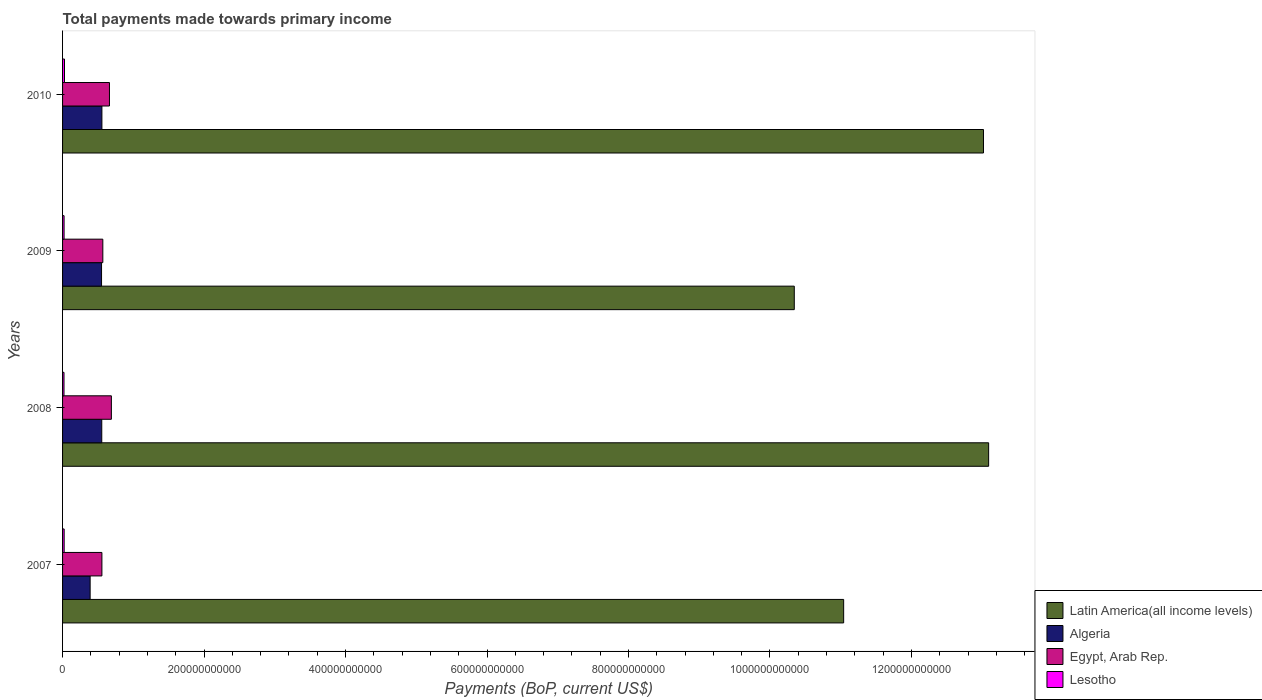How many groups of bars are there?
Offer a terse response. 4. Are the number of bars per tick equal to the number of legend labels?
Offer a very short reply. Yes. Are the number of bars on each tick of the Y-axis equal?
Your answer should be very brief. Yes. How many bars are there on the 1st tick from the top?
Make the answer very short. 4. How many bars are there on the 4th tick from the bottom?
Ensure brevity in your answer.  4. In how many cases, is the number of bars for a given year not equal to the number of legend labels?
Offer a very short reply. 0. What is the total payments made towards primary income in Latin America(all income levels) in 2010?
Make the answer very short. 1.30e+12. Across all years, what is the maximum total payments made towards primary income in Algeria?
Ensure brevity in your answer.  5.56e+1. Across all years, what is the minimum total payments made towards primary income in Latin America(all income levels)?
Offer a very short reply. 1.03e+12. In which year was the total payments made towards primary income in Algeria minimum?
Make the answer very short. 2007. What is the total total payments made towards primary income in Algeria in the graph?
Keep it short and to the point. 2.05e+11. What is the difference between the total payments made towards primary income in Lesotho in 2008 and that in 2009?
Offer a very short reply. -1.04e+08. What is the difference between the total payments made towards primary income in Egypt, Arab Rep. in 2008 and the total payments made towards primary income in Latin America(all income levels) in 2007?
Provide a succinct answer. -1.04e+12. What is the average total payments made towards primary income in Algeria per year?
Give a very brief answer. 5.13e+1. In the year 2008, what is the difference between the total payments made towards primary income in Algeria and total payments made towards primary income in Latin America(all income levels)?
Your answer should be very brief. -1.25e+12. What is the ratio of the total payments made towards primary income in Lesotho in 2008 to that in 2009?
Your response must be concise. 0.95. Is the total payments made towards primary income in Lesotho in 2007 less than that in 2010?
Provide a succinct answer. Yes. Is the difference between the total payments made towards primary income in Algeria in 2008 and 2009 greater than the difference between the total payments made towards primary income in Latin America(all income levels) in 2008 and 2009?
Ensure brevity in your answer.  No. What is the difference between the highest and the second highest total payments made towards primary income in Latin America(all income levels)?
Your answer should be compact. 7.28e+09. What is the difference between the highest and the lowest total payments made towards primary income in Algeria?
Keep it short and to the point. 1.66e+1. Is the sum of the total payments made towards primary income in Lesotho in 2007 and 2009 greater than the maximum total payments made towards primary income in Egypt, Arab Rep. across all years?
Ensure brevity in your answer.  No. Is it the case that in every year, the sum of the total payments made towards primary income in Egypt, Arab Rep. and total payments made towards primary income in Algeria is greater than the sum of total payments made towards primary income in Lesotho and total payments made towards primary income in Latin America(all income levels)?
Offer a very short reply. No. What does the 4th bar from the top in 2008 represents?
Keep it short and to the point. Latin America(all income levels). What does the 1st bar from the bottom in 2010 represents?
Offer a terse response. Latin America(all income levels). Are all the bars in the graph horizontal?
Your response must be concise. Yes. How many years are there in the graph?
Offer a very short reply. 4. What is the difference between two consecutive major ticks on the X-axis?
Your answer should be compact. 2.00e+11. Are the values on the major ticks of X-axis written in scientific E-notation?
Your response must be concise. No. Does the graph contain grids?
Offer a very short reply. No. How many legend labels are there?
Give a very brief answer. 4. What is the title of the graph?
Your answer should be very brief. Total payments made towards primary income. What is the label or title of the X-axis?
Keep it short and to the point. Payments (BoP, current US$). What is the Payments (BoP, current US$) in Latin America(all income levels) in 2007?
Make the answer very short. 1.10e+12. What is the Payments (BoP, current US$) in Algeria in 2007?
Offer a terse response. 3.90e+1. What is the Payments (BoP, current US$) in Egypt, Arab Rep. in 2007?
Keep it short and to the point. 5.56e+1. What is the Payments (BoP, current US$) in Lesotho in 2007?
Offer a terse response. 2.25e+09. What is the Payments (BoP, current US$) in Latin America(all income levels) in 2008?
Your answer should be very brief. 1.31e+12. What is the Payments (BoP, current US$) of Algeria in 2008?
Offer a very short reply. 5.54e+1. What is the Payments (BoP, current US$) of Egypt, Arab Rep. in 2008?
Provide a short and direct response. 6.90e+1. What is the Payments (BoP, current US$) in Lesotho in 2008?
Your response must be concise. 2.03e+09. What is the Payments (BoP, current US$) of Latin America(all income levels) in 2009?
Offer a very short reply. 1.03e+12. What is the Payments (BoP, current US$) of Algeria in 2009?
Your answer should be very brief. 5.51e+1. What is the Payments (BoP, current US$) of Egypt, Arab Rep. in 2009?
Keep it short and to the point. 5.69e+1. What is the Payments (BoP, current US$) in Lesotho in 2009?
Provide a short and direct response. 2.14e+09. What is the Payments (BoP, current US$) of Latin America(all income levels) in 2010?
Ensure brevity in your answer.  1.30e+12. What is the Payments (BoP, current US$) of Algeria in 2010?
Offer a terse response. 5.56e+1. What is the Payments (BoP, current US$) in Egypt, Arab Rep. in 2010?
Ensure brevity in your answer.  6.63e+1. What is the Payments (BoP, current US$) in Lesotho in 2010?
Offer a terse response. 2.74e+09. Across all years, what is the maximum Payments (BoP, current US$) of Latin America(all income levels)?
Your answer should be very brief. 1.31e+12. Across all years, what is the maximum Payments (BoP, current US$) of Algeria?
Your response must be concise. 5.56e+1. Across all years, what is the maximum Payments (BoP, current US$) in Egypt, Arab Rep.?
Keep it short and to the point. 6.90e+1. Across all years, what is the maximum Payments (BoP, current US$) of Lesotho?
Ensure brevity in your answer.  2.74e+09. Across all years, what is the minimum Payments (BoP, current US$) in Latin America(all income levels)?
Offer a very short reply. 1.03e+12. Across all years, what is the minimum Payments (BoP, current US$) in Algeria?
Offer a very short reply. 3.90e+1. Across all years, what is the minimum Payments (BoP, current US$) of Egypt, Arab Rep.?
Offer a very short reply. 5.56e+1. Across all years, what is the minimum Payments (BoP, current US$) in Lesotho?
Make the answer very short. 2.03e+09. What is the total Payments (BoP, current US$) in Latin America(all income levels) in the graph?
Provide a short and direct response. 4.75e+12. What is the total Payments (BoP, current US$) in Algeria in the graph?
Keep it short and to the point. 2.05e+11. What is the total Payments (BoP, current US$) in Egypt, Arab Rep. in the graph?
Provide a succinct answer. 2.48e+11. What is the total Payments (BoP, current US$) of Lesotho in the graph?
Your answer should be very brief. 9.17e+09. What is the difference between the Payments (BoP, current US$) in Latin America(all income levels) in 2007 and that in 2008?
Your response must be concise. -2.05e+11. What is the difference between the Payments (BoP, current US$) of Algeria in 2007 and that in 2008?
Make the answer very short. -1.64e+1. What is the difference between the Payments (BoP, current US$) in Egypt, Arab Rep. in 2007 and that in 2008?
Make the answer very short. -1.34e+1. What is the difference between the Payments (BoP, current US$) of Lesotho in 2007 and that in 2008?
Give a very brief answer. 2.17e+08. What is the difference between the Payments (BoP, current US$) in Latin America(all income levels) in 2007 and that in 2009?
Your answer should be compact. 6.98e+1. What is the difference between the Payments (BoP, current US$) in Algeria in 2007 and that in 2009?
Keep it short and to the point. -1.61e+1. What is the difference between the Payments (BoP, current US$) in Egypt, Arab Rep. in 2007 and that in 2009?
Your response must be concise. -1.29e+09. What is the difference between the Payments (BoP, current US$) of Lesotho in 2007 and that in 2009?
Your response must be concise. 1.13e+08. What is the difference between the Payments (BoP, current US$) of Latin America(all income levels) in 2007 and that in 2010?
Offer a very short reply. -1.98e+11. What is the difference between the Payments (BoP, current US$) in Algeria in 2007 and that in 2010?
Ensure brevity in your answer.  -1.66e+1. What is the difference between the Payments (BoP, current US$) of Egypt, Arab Rep. in 2007 and that in 2010?
Your response must be concise. -1.07e+1. What is the difference between the Payments (BoP, current US$) in Lesotho in 2007 and that in 2010?
Keep it short and to the point. -4.89e+08. What is the difference between the Payments (BoP, current US$) in Latin America(all income levels) in 2008 and that in 2009?
Ensure brevity in your answer.  2.75e+11. What is the difference between the Payments (BoP, current US$) in Algeria in 2008 and that in 2009?
Give a very brief answer. 2.97e+08. What is the difference between the Payments (BoP, current US$) in Egypt, Arab Rep. in 2008 and that in 2009?
Your answer should be very brief. 1.21e+1. What is the difference between the Payments (BoP, current US$) in Lesotho in 2008 and that in 2009?
Offer a terse response. -1.04e+08. What is the difference between the Payments (BoP, current US$) of Latin America(all income levels) in 2008 and that in 2010?
Provide a short and direct response. 7.28e+09. What is the difference between the Payments (BoP, current US$) of Algeria in 2008 and that in 2010?
Your answer should be compact. -2.06e+08. What is the difference between the Payments (BoP, current US$) of Egypt, Arab Rep. in 2008 and that in 2010?
Keep it short and to the point. 2.69e+09. What is the difference between the Payments (BoP, current US$) of Lesotho in 2008 and that in 2010?
Keep it short and to the point. -7.06e+08. What is the difference between the Payments (BoP, current US$) of Latin America(all income levels) in 2009 and that in 2010?
Ensure brevity in your answer.  -2.67e+11. What is the difference between the Payments (BoP, current US$) in Algeria in 2009 and that in 2010?
Your answer should be compact. -5.04e+08. What is the difference between the Payments (BoP, current US$) in Egypt, Arab Rep. in 2009 and that in 2010?
Ensure brevity in your answer.  -9.40e+09. What is the difference between the Payments (BoP, current US$) of Lesotho in 2009 and that in 2010?
Make the answer very short. -6.02e+08. What is the difference between the Payments (BoP, current US$) in Latin America(all income levels) in 2007 and the Payments (BoP, current US$) in Algeria in 2008?
Keep it short and to the point. 1.05e+12. What is the difference between the Payments (BoP, current US$) in Latin America(all income levels) in 2007 and the Payments (BoP, current US$) in Egypt, Arab Rep. in 2008?
Make the answer very short. 1.04e+12. What is the difference between the Payments (BoP, current US$) of Latin America(all income levels) in 2007 and the Payments (BoP, current US$) of Lesotho in 2008?
Your answer should be very brief. 1.10e+12. What is the difference between the Payments (BoP, current US$) in Algeria in 2007 and the Payments (BoP, current US$) in Egypt, Arab Rep. in 2008?
Provide a short and direct response. -3.00e+1. What is the difference between the Payments (BoP, current US$) in Algeria in 2007 and the Payments (BoP, current US$) in Lesotho in 2008?
Your answer should be very brief. 3.69e+1. What is the difference between the Payments (BoP, current US$) in Egypt, Arab Rep. in 2007 and the Payments (BoP, current US$) in Lesotho in 2008?
Your answer should be very brief. 5.36e+1. What is the difference between the Payments (BoP, current US$) in Latin America(all income levels) in 2007 and the Payments (BoP, current US$) in Algeria in 2009?
Provide a succinct answer. 1.05e+12. What is the difference between the Payments (BoP, current US$) of Latin America(all income levels) in 2007 and the Payments (BoP, current US$) of Egypt, Arab Rep. in 2009?
Ensure brevity in your answer.  1.05e+12. What is the difference between the Payments (BoP, current US$) in Latin America(all income levels) in 2007 and the Payments (BoP, current US$) in Lesotho in 2009?
Ensure brevity in your answer.  1.10e+12. What is the difference between the Payments (BoP, current US$) in Algeria in 2007 and the Payments (BoP, current US$) in Egypt, Arab Rep. in 2009?
Ensure brevity in your answer.  -1.79e+1. What is the difference between the Payments (BoP, current US$) of Algeria in 2007 and the Payments (BoP, current US$) of Lesotho in 2009?
Provide a short and direct response. 3.68e+1. What is the difference between the Payments (BoP, current US$) of Egypt, Arab Rep. in 2007 and the Payments (BoP, current US$) of Lesotho in 2009?
Keep it short and to the point. 5.35e+1. What is the difference between the Payments (BoP, current US$) in Latin America(all income levels) in 2007 and the Payments (BoP, current US$) in Algeria in 2010?
Your answer should be very brief. 1.05e+12. What is the difference between the Payments (BoP, current US$) in Latin America(all income levels) in 2007 and the Payments (BoP, current US$) in Egypt, Arab Rep. in 2010?
Keep it short and to the point. 1.04e+12. What is the difference between the Payments (BoP, current US$) in Latin America(all income levels) in 2007 and the Payments (BoP, current US$) in Lesotho in 2010?
Keep it short and to the point. 1.10e+12. What is the difference between the Payments (BoP, current US$) in Algeria in 2007 and the Payments (BoP, current US$) in Egypt, Arab Rep. in 2010?
Offer a very short reply. -2.73e+1. What is the difference between the Payments (BoP, current US$) of Algeria in 2007 and the Payments (BoP, current US$) of Lesotho in 2010?
Your response must be concise. 3.62e+1. What is the difference between the Payments (BoP, current US$) in Egypt, Arab Rep. in 2007 and the Payments (BoP, current US$) in Lesotho in 2010?
Your response must be concise. 5.29e+1. What is the difference between the Payments (BoP, current US$) in Latin America(all income levels) in 2008 and the Payments (BoP, current US$) in Algeria in 2009?
Your answer should be compact. 1.25e+12. What is the difference between the Payments (BoP, current US$) in Latin America(all income levels) in 2008 and the Payments (BoP, current US$) in Egypt, Arab Rep. in 2009?
Your response must be concise. 1.25e+12. What is the difference between the Payments (BoP, current US$) in Latin America(all income levels) in 2008 and the Payments (BoP, current US$) in Lesotho in 2009?
Offer a terse response. 1.31e+12. What is the difference between the Payments (BoP, current US$) in Algeria in 2008 and the Payments (BoP, current US$) in Egypt, Arab Rep. in 2009?
Ensure brevity in your answer.  -1.50e+09. What is the difference between the Payments (BoP, current US$) of Algeria in 2008 and the Payments (BoP, current US$) of Lesotho in 2009?
Your response must be concise. 5.33e+1. What is the difference between the Payments (BoP, current US$) of Egypt, Arab Rep. in 2008 and the Payments (BoP, current US$) of Lesotho in 2009?
Ensure brevity in your answer.  6.69e+1. What is the difference between the Payments (BoP, current US$) of Latin America(all income levels) in 2008 and the Payments (BoP, current US$) of Algeria in 2010?
Ensure brevity in your answer.  1.25e+12. What is the difference between the Payments (BoP, current US$) in Latin America(all income levels) in 2008 and the Payments (BoP, current US$) in Egypt, Arab Rep. in 2010?
Your answer should be very brief. 1.24e+12. What is the difference between the Payments (BoP, current US$) of Latin America(all income levels) in 2008 and the Payments (BoP, current US$) of Lesotho in 2010?
Provide a short and direct response. 1.31e+12. What is the difference between the Payments (BoP, current US$) in Algeria in 2008 and the Payments (BoP, current US$) in Egypt, Arab Rep. in 2010?
Provide a succinct answer. -1.09e+1. What is the difference between the Payments (BoP, current US$) of Algeria in 2008 and the Payments (BoP, current US$) of Lesotho in 2010?
Your answer should be very brief. 5.27e+1. What is the difference between the Payments (BoP, current US$) of Egypt, Arab Rep. in 2008 and the Payments (BoP, current US$) of Lesotho in 2010?
Ensure brevity in your answer.  6.63e+1. What is the difference between the Payments (BoP, current US$) in Latin America(all income levels) in 2009 and the Payments (BoP, current US$) in Algeria in 2010?
Offer a very short reply. 9.79e+11. What is the difference between the Payments (BoP, current US$) of Latin America(all income levels) in 2009 and the Payments (BoP, current US$) of Egypt, Arab Rep. in 2010?
Provide a short and direct response. 9.68e+11. What is the difference between the Payments (BoP, current US$) in Latin America(all income levels) in 2009 and the Payments (BoP, current US$) in Lesotho in 2010?
Offer a terse response. 1.03e+12. What is the difference between the Payments (BoP, current US$) of Algeria in 2009 and the Payments (BoP, current US$) of Egypt, Arab Rep. in 2010?
Your answer should be very brief. -1.12e+1. What is the difference between the Payments (BoP, current US$) in Algeria in 2009 and the Payments (BoP, current US$) in Lesotho in 2010?
Your answer should be compact. 5.24e+1. What is the difference between the Payments (BoP, current US$) in Egypt, Arab Rep. in 2009 and the Payments (BoP, current US$) in Lesotho in 2010?
Ensure brevity in your answer.  5.42e+1. What is the average Payments (BoP, current US$) of Latin America(all income levels) per year?
Provide a succinct answer. 1.19e+12. What is the average Payments (BoP, current US$) of Algeria per year?
Your answer should be compact. 5.13e+1. What is the average Payments (BoP, current US$) of Egypt, Arab Rep. per year?
Keep it short and to the point. 6.20e+1. What is the average Payments (BoP, current US$) in Lesotho per year?
Make the answer very short. 2.29e+09. In the year 2007, what is the difference between the Payments (BoP, current US$) of Latin America(all income levels) and Payments (BoP, current US$) of Algeria?
Offer a terse response. 1.07e+12. In the year 2007, what is the difference between the Payments (BoP, current US$) in Latin America(all income levels) and Payments (BoP, current US$) in Egypt, Arab Rep.?
Provide a short and direct response. 1.05e+12. In the year 2007, what is the difference between the Payments (BoP, current US$) of Latin America(all income levels) and Payments (BoP, current US$) of Lesotho?
Offer a terse response. 1.10e+12. In the year 2007, what is the difference between the Payments (BoP, current US$) of Algeria and Payments (BoP, current US$) of Egypt, Arab Rep.?
Keep it short and to the point. -1.66e+1. In the year 2007, what is the difference between the Payments (BoP, current US$) of Algeria and Payments (BoP, current US$) of Lesotho?
Your answer should be very brief. 3.67e+1. In the year 2007, what is the difference between the Payments (BoP, current US$) in Egypt, Arab Rep. and Payments (BoP, current US$) in Lesotho?
Your answer should be very brief. 5.34e+1. In the year 2008, what is the difference between the Payments (BoP, current US$) in Latin America(all income levels) and Payments (BoP, current US$) in Algeria?
Your answer should be compact. 1.25e+12. In the year 2008, what is the difference between the Payments (BoP, current US$) of Latin America(all income levels) and Payments (BoP, current US$) of Egypt, Arab Rep.?
Provide a succinct answer. 1.24e+12. In the year 2008, what is the difference between the Payments (BoP, current US$) of Latin America(all income levels) and Payments (BoP, current US$) of Lesotho?
Your response must be concise. 1.31e+12. In the year 2008, what is the difference between the Payments (BoP, current US$) in Algeria and Payments (BoP, current US$) in Egypt, Arab Rep.?
Your answer should be compact. -1.36e+1. In the year 2008, what is the difference between the Payments (BoP, current US$) of Algeria and Payments (BoP, current US$) of Lesotho?
Your answer should be compact. 5.34e+1. In the year 2008, what is the difference between the Payments (BoP, current US$) in Egypt, Arab Rep. and Payments (BoP, current US$) in Lesotho?
Ensure brevity in your answer.  6.70e+1. In the year 2009, what is the difference between the Payments (BoP, current US$) in Latin America(all income levels) and Payments (BoP, current US$) in Algeria?
Provide a succinct answer. 9.79e+11. In the year 2009, what is the difference between the Payments (BoP, current US$) of Latin America(all income levels) and Payments (BoP, current US$) of Egypt, Arab Rep.?
Give a very brief answer. 9.77e+11. In the year 2009, what is the difference between the Payments (BoP, current US$) in Latin America(all income levels) and Payments (BoP, current US$) in Lesotho?
Your answer should be compact. 1.03e+12. In the year 2009, what is the difference between the Payments (BoP, current US$) in Algeria and Payments (BoP, current US$) in Egypt, Arab Rep.?
Offer a very short reply. -1.80e+09. In the year 2009, what is the difference between the Payments (BoP, current US$) in Algeria and Payments (BoP, current US$) in Lesotho?
Your answer should be very brief. 5.30e+1. In the year 2009, what is the difference between the Payments (BoP, current US$) of Egypt, Arab Rep. and Payments (BoP, current US$) of Lesotho?
Provide a succinct answer. 5.48e+1. In the year 2010, what is the difference between the Payments (BoP, current US$) in Latin America(all income levels) and Payments (BoP, current US$) in Algeria?
Your answer should be very brief. 1.25e+12. In the year 2010, what is the difference between the Payments (BoP, current US$) in Latin America(all income levels) and Payments (BoP, current US$) in Egypt, Arab Rep.?
Make the answer very short. 1.24e+12. In the year 2010, what is the difference between the Payments (BoP, current US$) in Latin America(all income levels) and Payments (BoP, current US$) in Lesotho?
Keep it short and to the point. 1.30e+12. In the year 2010, what is the difference between the Payments (BoP, current US$) in Algeria and Payments (BoP, current US$) in Egypt, Arab Rep.?
Make the answer very short. -1.07e+1. In the year 2010, what is the difference between the Payments (BoP, current US$) in Algeria and Payments (BoP, current US$) in Lesotho?
Ensure brevity in your answer.  5.29e+1. In the year 2010, what is the difference between the Payments (BoP, current US$) of Egypt, Arab Rep. and Payments (BoP, current US$) of Lesotho?
Give a very brief answer. 6.36e+1. What is the ratio of the Payments (BoP, current US$) in Latin America(all income levels) in 2007 to that in 2008?
Provide a short and direct response. 0.84. What is the ratio of the Payments (BoP, current US$) of Algeria in 2007 to that in 2008?
Provide a succinct answer. 0.7. What is the ratio of the Payments (BoP, current US$) of Egypt, Arab Rep. in 2007 to that in 2008?
Provide a succinct answer. 0.81. What is the ratio of the Payments (BoP, current US$) in Lesotho in 2007 to that in 2008?
Your answer should be very brief. 1.11. What is the ratio of the Payments (BoP, current US$) of Latin America(all income levels) in 2007 to that in 2009?
Give a very brief answer. 1.07. What is the ratio of the Payments (BoP, current US$) of Algeria in 2007 to that in 2009?
Your response must be concise. 0.71. What is the ratio of the Payments (BoP, current US$) of Egypt, Arab Rep. in 2007 to that in 2009?
Provide a succinct answer. 0.98. What is the ratio of the Payments (BoP, current US$) of Lesotho in 2007 to that in 2009?
Give a very brief answer. 1.05. What is the ratio of the Payments (BoP, current US$) in Latin America(all income levels) in 2007 to that in 2010?
Ensure brevity in your answer.  0.85. What is the ratio of the Payments (BoP, current US$) of Algeria in 2007 to that in 2010?
Your response must be concise. 0.7. What is the ratio of the Payments (BoP, current US$) in Egypt, Arab Rep. in 2007 to that in 2010?
Your response must be concise. 0.84. What is the ratio of the Payments (BoP, current US$) in Lesotho in 2007 to that in 2010?
Offer a terse response. 0.82. What is the ratio of the Payments (BoP, current US$) of Latin America(all income levels) in 2008 to that in 2009?
Your answer should be compact. 1.27. What is the ratio of the Payments (BoP, current US$) of Algeria in 2008 to that in 2009?
Give a very brief answer. 1.01. What is the ratio of the Payments (BoP, current US$) in Egypt, Arab Rep. in 2008 to that in 2009?
Ensure brevity in your answer.  1.21. What is the ratio of the Payments (BoP, current US$) of Lesotho in 2008 to that in 2009?
Provide a succinct answer. 0.95. What is the ratio of the Payments (BoP, current US$) of Latin America(all income levels) in 2008 to that in 2010?
Keep it short and to the point. 1.01. What is the ratio of the Payments (BoP, current US$) of Algeria in 2008 to that in 2010?
Your answer should be very brief. 1. What is the ratio of the Payments (BoP, current US$) in Egypt, Arab Rep. in 2008 to that in 2010?
Give a very brief answer. 1.04. What is the ratio of the Payments (BoP, current US$) of Lesotho in 2008 to that in 2010?
Give a very brief answer. 0.74. What is the ratio of the Payments (BoP, current US$) in Latin America(all income levels) in 2009 to that in 2010?
Provide a short and direct response. 0.79. What is the ratio of the Payments (BoP, current US$) of Algeria in 2009 to that in 2010?
Make the answer very short. 0.99. What is the ratio of the Payments (BoP, current US$) in Egypt, Arab Rep. in 2009 to that in 2010?
Your answer should be compact. 0.86. What is the ratio of the Payments (BoP, current US$) of Lesotho in 2009 to that in 2010?
Offer a very short reply. 0.78. What is the difference between the highest and the second highest Payments (BoP, current US$) in Latin America(all income levels)?
Give a very brief answer. 7.28e+09. What is the difference between the highest and the second highest Payments (BoP, current US$) in Algeria?
Your answer should be very brief. 2.06e+08. What is the difference between the highest and the second highest Payments (BoP, current US$) of Egypt, Arab Rep.?
Make the answer very short. 2.69e+09. What is the difference between the highest and the second highest Payments (BoP, current US$) of Lesotho?
Offer a terse response. 4.89e+08. What is the difference between the highest and the lowest Payments (BoP, current US$) in Latin America(all income levels)?
Offer a very short reply. 2.75e+11. What is the difference between the highest and the lowest Payments (BoP, current US$) in Algeria?
Keep it short and to the point. 1.66e+1. What is the difference between the highest and the lowest Payments (BoP, current US$) of Egypt, Arab Rep.?
Your answer should be very brief. 1.34e+1. What is the difference between the highest and the lowest Payments (BoP, current US$) of Lesotho?
Provide a succinct answer. 7.06e+08. 